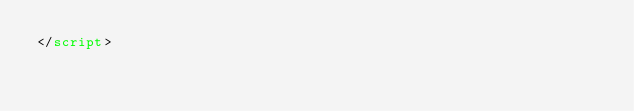Convert code to text. <code><loc_0><loc_0><loc_500><loc_500><_HTML_></script>
</code> 